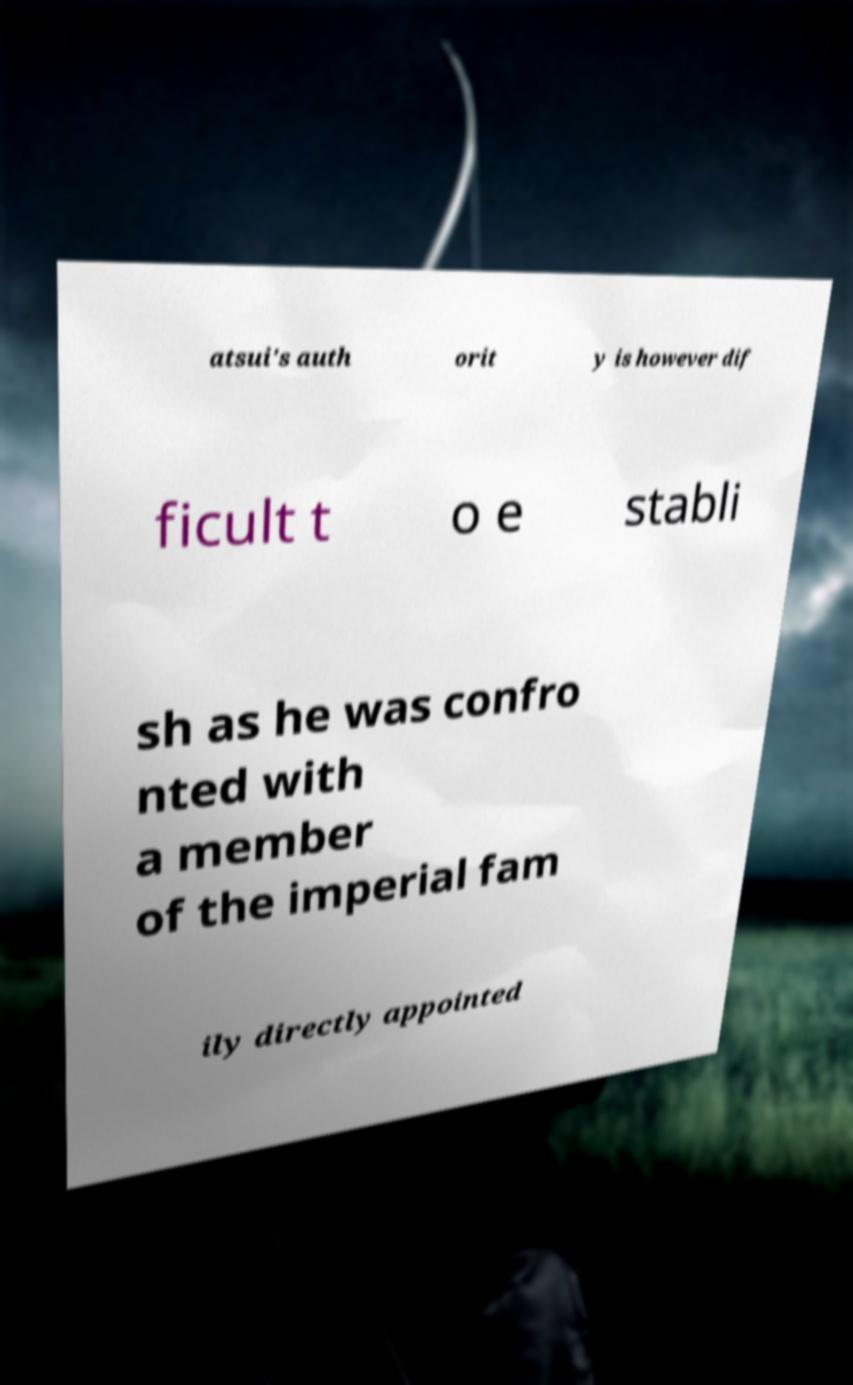For documentation purposes, I need the text within this image transcribed. Could you provide that? atsui's auth orit y is however dif ficult t o e stabli sh as he was confro nted with a member of the imperial fam ily directly appointed 